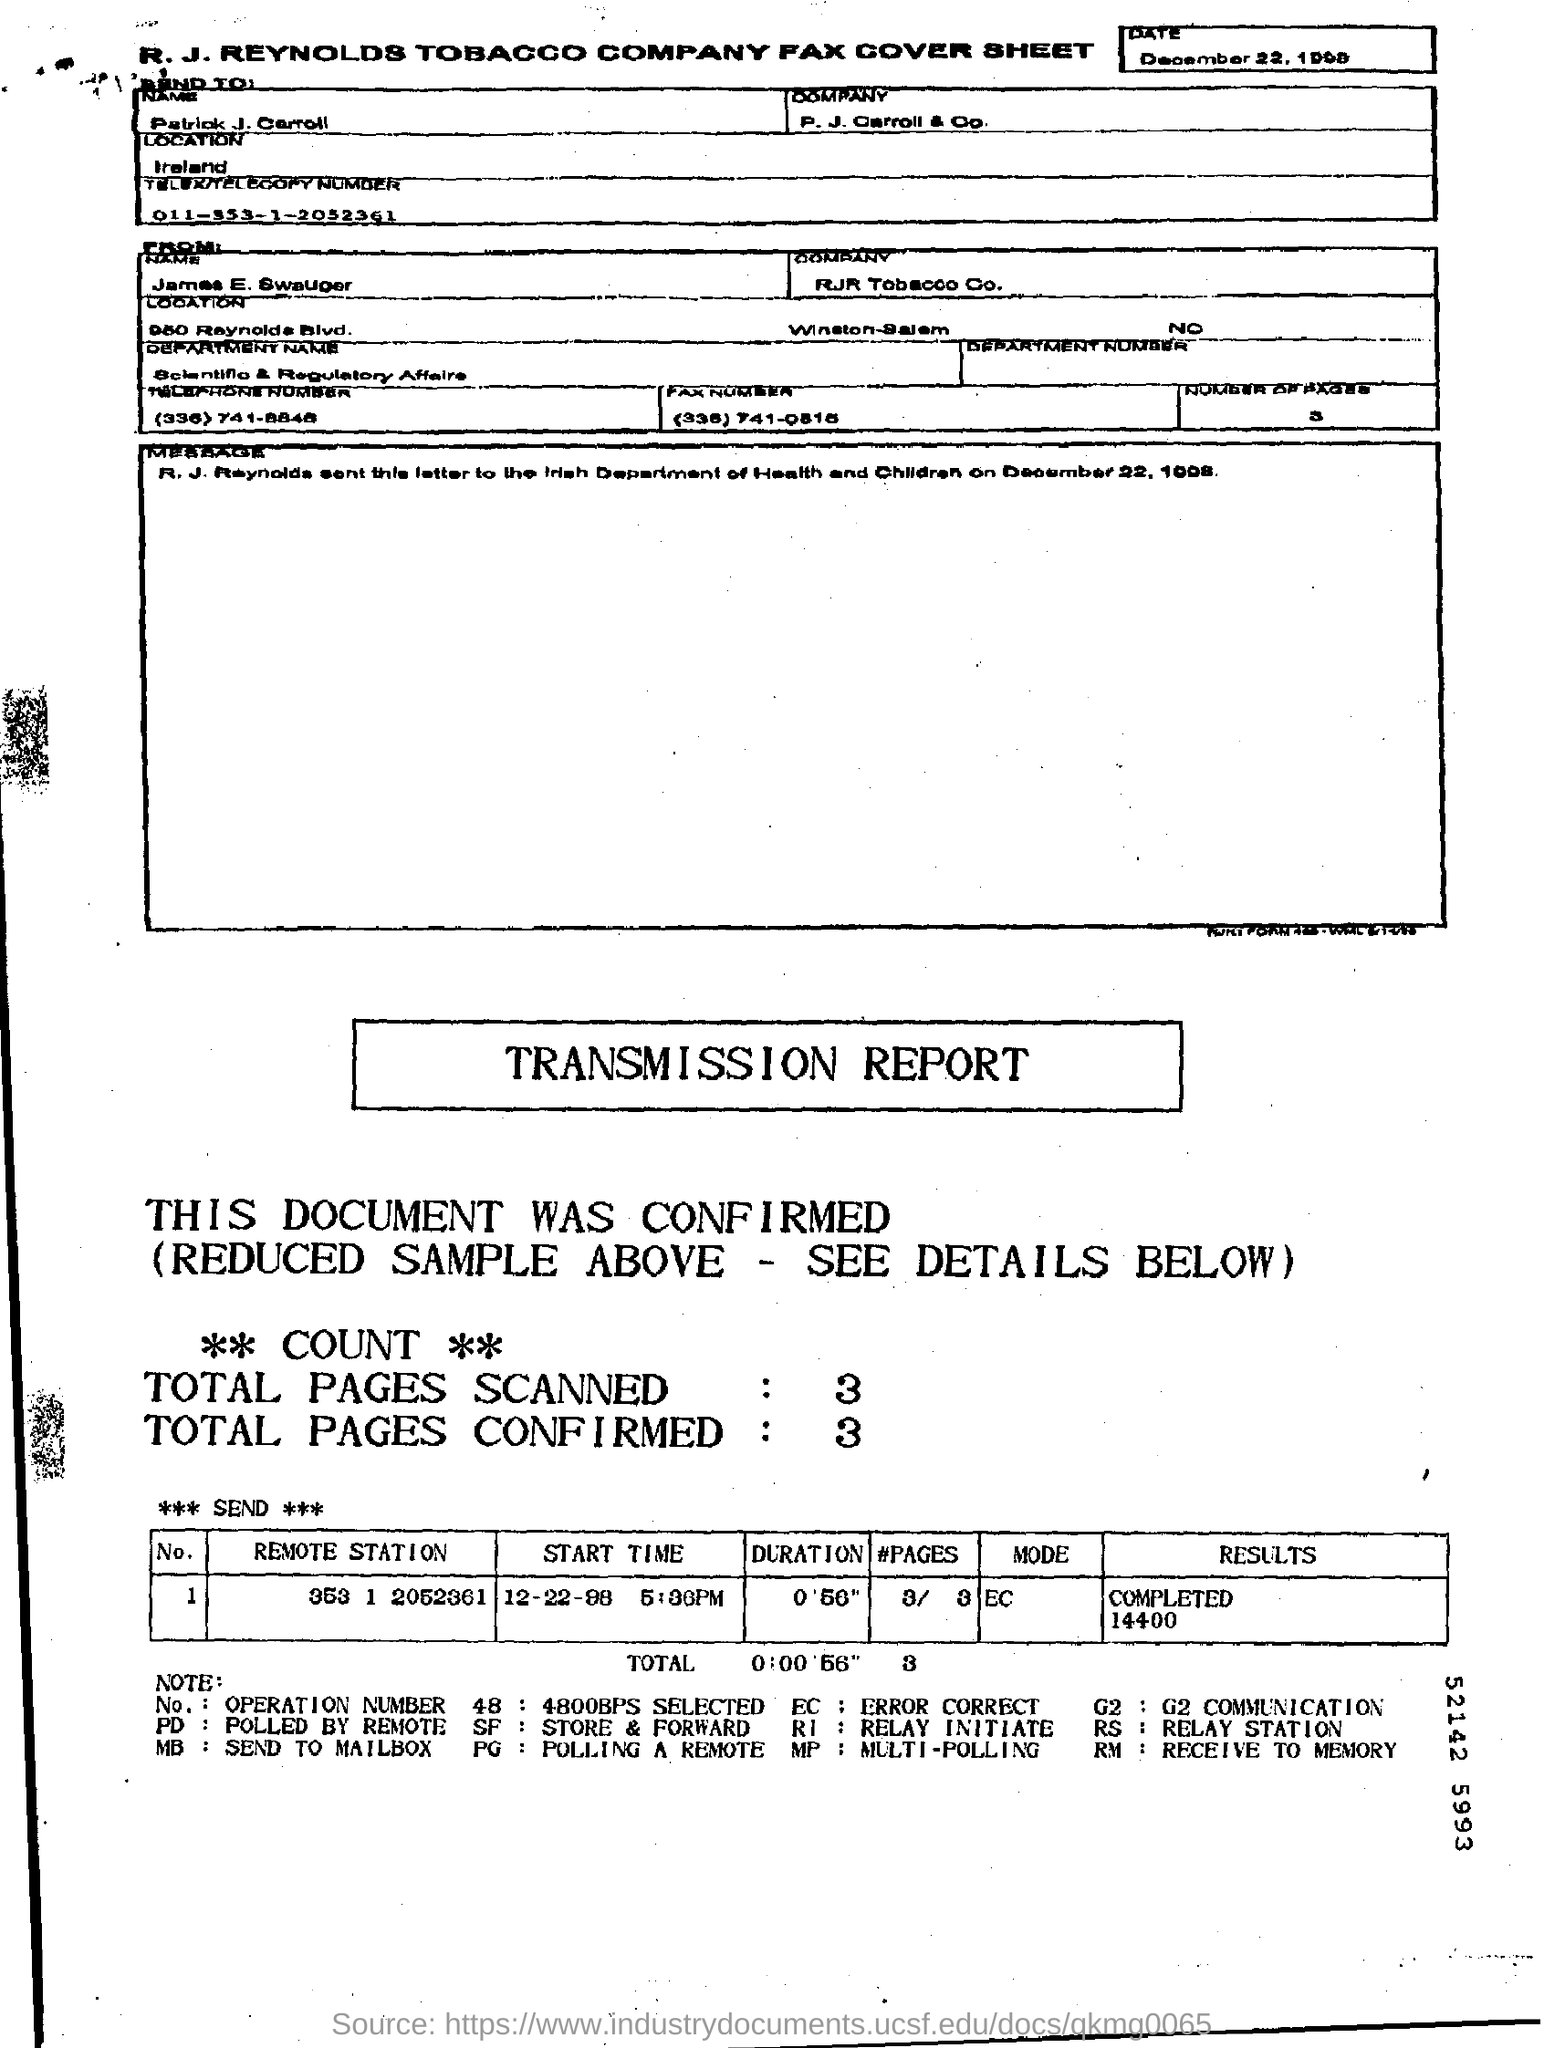To whom is fax sent?
Make the answer very short. Patrick J. Carroll. For which company does Patrick J. Carroll work?
Offer a terse response. P. J. Carroll & Co. Which department is James from?
Give a very brief answer. Scientific & Regulatory Affairs. 